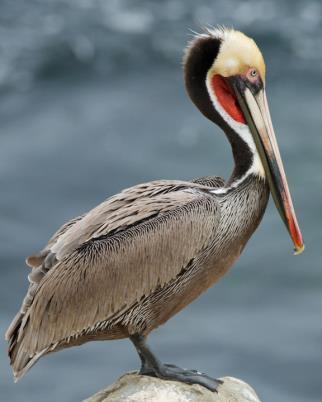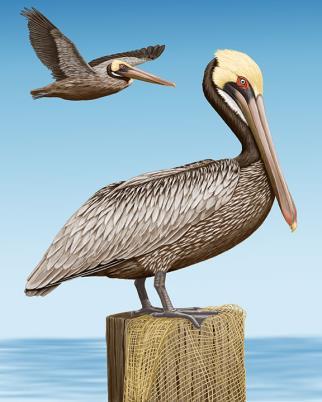The first image is the image on the left, the second image is the image on the right. Evaluate the accuracy of this statement regarding the images: "A bird is perched on a rock.". Is it true? Answer yes or no. Yes. The first image is the image on the left, the second image is the image on the right. Examine the images to the left and right. Is the description "Two long-beaked birds are shown in flight, both with wings outspread, but one with them pointed downward, and the other with them pointed upward." accurate? Answer yes or no. No. 